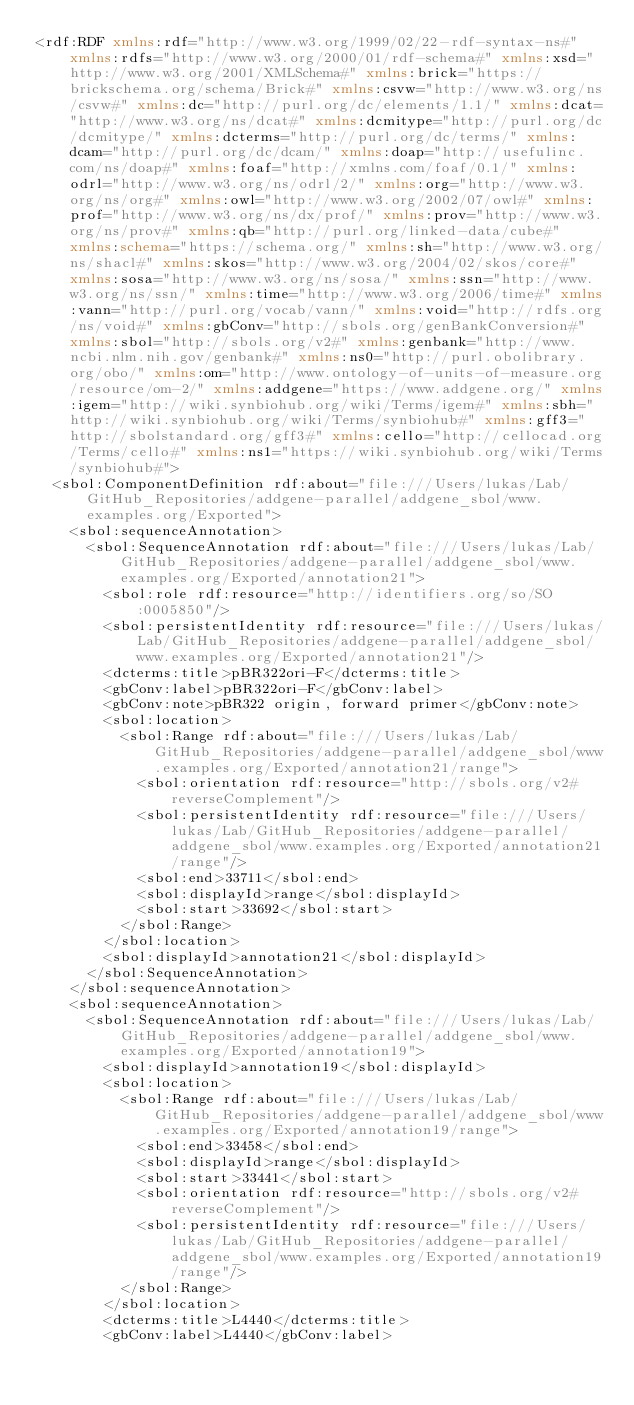Convert code to text. <code><loc_0><loc_0><loc_500><loc_500><_XML_><rdf:RDF xmlns:rdf="http://www.w3.org/1999/02/22-rdf-syntax-ns#" xmlns:rdfs="http://www.w3.org/2000/01/rdf-schema#" xmlns:xsd="http://www.w3.org/2001/XMLSchema#" xmlns:brick="https://brickschema.org/schema/Brick#" xmlns:csvw="http://www.w3.org/ns/csvw#" xmlns:dc="http://purl.org/dc/elements/1.1/" xmlns:dcat="http://www.w3.org/ns/dcat#" xmlns:dcmitype="http://purl.org/dc/dcmitype/" xmlns:dcterms="http://purl.org/dc/terms/" xmlns:dcam="http://purl.org/dc/dcam/" xmlns:doap="http://usefulinc.com/ns/doap#" xmlns:foaf="http://xmlns.com/foaf/0.1/" xmlns:odrl="http://www.w3.org/ns/odrl/2/" xmlns:org="http://www.w3.org/ns/org#" xmlns:owl="http://www.w3.org/2002/07/owl#" xmlns:prof="http://www.w3.org/ns/dx/prof/" xmlns:prov="http://www.w3.org/ns/prov#" xmlns:qb="http://purl.org/linked-data/cube#" xmlns:schema="https://schema.org/" xmlns:sh="http://www.w3.org/ns/shacl#" xmlns:skos="http://www.w3.org/2004/02/skos/core#" xmlns:sosa="http://www.w3.org/ns/sosa/" xmlns:ssn="http://www.w3.org/ns/ssn/" xmlns:time="http://www.w3.org/2006/time#" xmlns:vann="http://purl.org/vocab/vann/" xmlns:void="http://rdfs.org/ns/void#" xmlns:gbConv="http://sbols.org/genBankConversion#" xmlns:sbol="http://sbols.org/v2#" xmlns:genbank="http://www.ncbi.nlm.nih.gov/genbank#" xmlns:ns0="http://purl.obolibrary.org/obo/" xmlns:om="http://www.ontology-of-units-of-measure.org/resource/om-2/" xmlns:addgene="https://www.addgene.org/" xmlns:igem="http://wiki.synbiohub.org/wiki/Terms/igem#" xmlns:sbh="http://wiki.synbiohub.org/wiki/Terms/synbiohub#" xmlns:gff3="http://sbolstandard.org/gff3#" xmlns:cello="http://cellocad.org/Terms/cello#" xmlns:ns1="https://wiki.synbiohub.org/wiki/Terms/synbiohub#">
  <sbol:ComponentDefinition rdf:about="file:///Users/lukas/Lab/GitHub_Repositories/addgene-parallel/addgene_sbol/www.examples.org/Exported">
    <sbol:sequenceAnnotation>
      <sbol:SequenceAnnotation rdf:about="file:///Users/lukas/Lab/GitHub_Repositories/addgene-parallel/addgene_sbol/www.examples.org/Exported/annotation21">
        <sbol:role rdf:resource="http://identifiers.org/so/SO:0005850"/>
        <sbol:persistentIdentity rdf:resource="file:///Users/lukas/Lab/GitHub_Repositories/addgene-parallel/addgene_sbol/www.examples.org/Exported/annotation21"/>
        <dcterms:title>pBR322ori-F</dcterms:title>
        <gbConv:label>pBR322ori-F</gbConv:label>
        <gbConv:note>pBR322 origin, forward primer</gbConv:note>
        <sbol:location>
          <sbol:Range rdf:about="file:///Users/lukas/Lab/GitHub_Repositories/addgene-parallel/addgene_sbol/www.examples.org/Exported/annotation21/range">
            <sbol:orientation rdf:resource="http://sbols.org/v2#reverseComplement"/>
            <sbol:persistentIdentity rdf:resource="file:///Users/lukas/Lab/GitHub_Repositories/addgene-parallel/addgene_sbol/www.examples.org/Exported/annotation21/range"/>
            <sbol:end>33711</sbol:end>
            <sbol:displayId>range</sbol:displayId>
            <sbol:start>33692</sbol:start>
          </sbol:Range>
        </sbol:location>
        <sbol:displayId>annotation21</sbol:displayId>
      </sbol:SequenceAnnotation>
    </sbol:sequenceAnnotation>
    <sbol:sequenceAnnotation>
      <sbol:SequenceAnnotation rdf:about="file:///Users/lukas/Lab/GitHub_Repositories/addgene-parallel/addgene_sbol/www.examples.org/Exported/annotation19">
        <sbol:displayId>annotation19</sbol:displayId>
        <sbol:location>
          <sbol:Range rdf:about="file:///Users/lukas/Lab/GitHub_Repositories/addgene-parallel/addgene_sbol/www.examples.org/Exported/annotation19/range">
            <sbol:end>33458</sbol:end>
            <sbol:displayId>range</sbol:displayId>
            <sbol:start>33441</sbol:start>
            <sbol:orientation rdf:resource="http://sbols.org/v2#reverseComplement"/>
            <sbol:persistentIdentity rdf:resource="file:///Users/lukas/Lab/GitHub_Repositories/addgene-parallel/addgene_sbol/www.examples.org/Exported/annotation19/range"/>
          </sbol:Range>
        </sbol:location>
        <dcterms:title>L4440</dcterms:title>
        <gbConv:label>L4440</gbConv:label></code> 